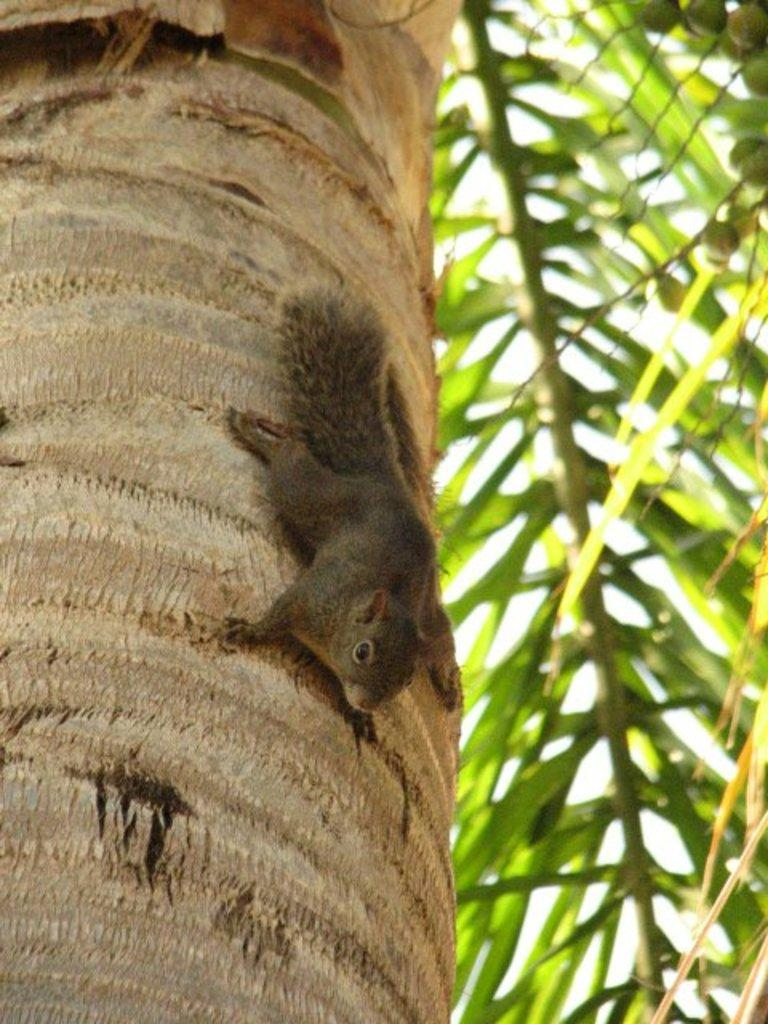What is the main object in the image? There is a tree trunk in the image. Is there any animal on the tree trunk? Yes, a squirrel is present on the tree trunk. What type of vegetation is visible in the image? There are coconut leaves in the image. What type of loaf is being used as a seat by the squirrel in the image? There is no loaf present in the image; the squirrel is sitting on the tree trunk. 